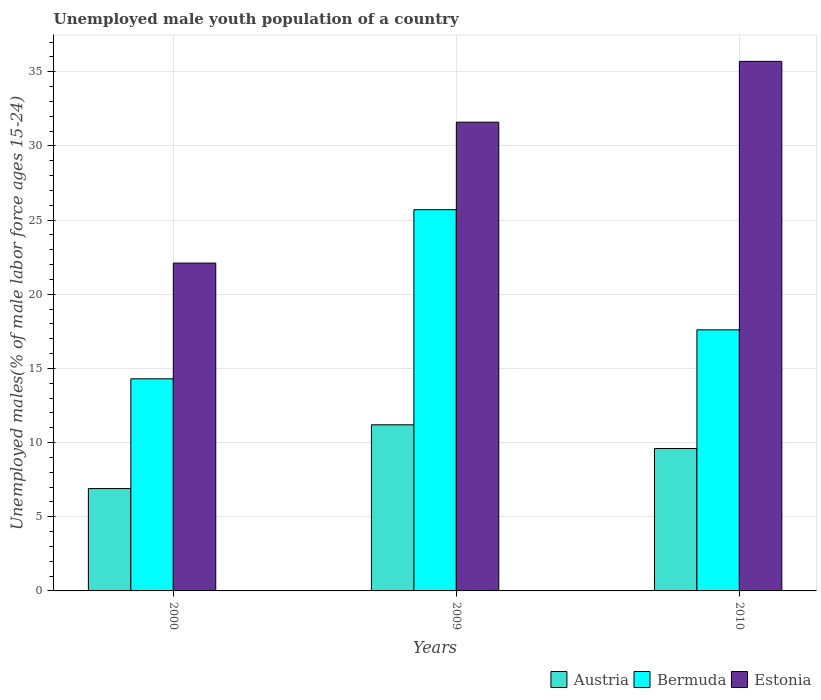Are the number of bars on each tick of the X-axis equal?
Your response must be concise. Yes. How many bars are there on the 3rd tick from the left?
Your answer should be very brief. 3. How many bars are there on the 2nd tick from the right?
Your answer should be very brief. 3. What is the percentage of unemployed male youth population in Estonia in 2000?
Ensure brevity in your answer.  22.1. Across all years, what is the maximum percentage of unemployed male youth population in Bermuda?
Provide a succinct answer. 25.7. Across all years, what is the minimum percentage of unemployed male youth population in Estonia?
Offer a very short reply. 22.1. In which year was the percentage of unemployed male youth population in Estonia minimum?
Provide a short and direct response. 2000. What is the total percentage of unemployed male youth population in Bermuda in the graph?
Ensure brevity in your answer.  57.6. What is the difference between the percentage of unemployed male youth population in Bermuda in 2000 and that in 2010?
Offer a very short reply. -3.3. What is the difference between the percentage of unemployed male youth population in Bermuda in 2000 and the percentage of unemployed male youth population in Austria in 2010?
Give a very brief answer. 4.7. What is the average percentage of unemployed male youth population in Austria per year?
Provide a succinct answer. 9.23. In the year 2010, what is the difference between the percentage of unemployed male youth population in Austria and percentage of unemployed male youth population in Estonia?
Your answer should be very brief. -26.1. In how many years, is the percentage of unemployed male youth population in Austria greater than 35 %?
Make the answer very short. 0. What is the ratio of the percentage of unemployed male youth population in Bermuda in 2000 to that in 2009?
Provide a short and direct response. 0.56. Is the percentage of unemployed male youth population in Bermuda in 2009 less than that in 2010?
Make the answer very short. No. What is the difference between the highest and the second highest percentage of unemployed male youth population in Estonia?
Provide a short and direct response. 4.1. What is the difference between the highest and the lowest percentage of unemployed male youth population in Austria?
Your answer should be very brief. 4.3. Is the sum of the percentage of unemployed male youth population in Austria in 2009 and 2010 greater than the maximum percentage of unemployed male youth population in Estonia across all years?
Your response must be concise. No. Are all the bars in the graph horizontal?
Offer a very short reply. No. How many legend labels are there?
Your answer should be compact. 3. How are the legend labels stacked?
Offer a terse response. Horizontal. What is the title of the graph?
Offer a very short reply. Unemployed male youth population of a country. Does "Singapore" appear as one of the legend labels in the graph?
Make the answer very short. No. What is the label or title of the X-axis?
Provide a short and direct response. Years. What is the label or title of the Y-axis?
Your answer should be very brief. Unemployed males(% of male labor force ages 15-24). What is the Unemployed males(% of male labor force ages 15-24) in Austria in 2000?
Your answer should be very brief. 6.9. What is the Unemployed males(% of male labor force ages 15-24) of Bermuda in 2000?
Your response must be concise. 14.3. What is the Unemployed males(% of male labor force ages 15-24) in Estonia in 2000?
Your answer should be very brief. 22.1. What is the Unemployed males(% of male labor force ages 15-24) in Austria in 2009?
Provide a succinct answer. 11.2. What is the Unemployed males(% of male labor force ages 15-24) of Bermuda in 2009?
Give a very brief answer. 25.7. What is the Unemployed males(% of male labor force ages 15-24) of Estonia in 2009?
Provide a short and direct response. 31.6. What is the Unemployed males(% of male labor force ages 15-24) of Austria in 2010?
Your answer should be very brief. 9.6. What is the Unemployed males(% of male labor force ages 15-24) of Bermuda in 2010?
Make the answer very short. 17.6. What is the Unemployed males(% of male labor force ages 15-24) of Estonia in 2010?
Give a very brief answer. 35.7. Across all years, what is the maximum Unemployed males(% of male labor force ages 15-24) in Austria?
Make the answer very short. 11.2. Across all years, what is the maximum Unemployed males(% of male labor force ages 15-24) of Bermuda?
Give a very brief answer. 25.7. Across all years, what is the maximum Unemployed males(% of male labor force ages 15-24) of Estonia?
Your answer should be compact. 35.7. Across all years, what is the minimum Unemployed males(% of male labor force ages 15-24) in Austria?
Ensure brevity in your answer.  6.9. Across all years, what is the minimum Unemployed males(% of male labor force ages 15-24) of Bermuda?
Offer a very short reply. 14.3. Across all years, what is the minimum Unemployed males(% of male labor force ages 15-24) of Estonia?
Provide a short and direct response. 22.1. What is the total Unemployed males(% of male labor force ages 15-24) in Austria in the graph?
Provide a short and direct response. 27.7. What is the total Unemployed males(% of male labor force ages 15-24) in Bermuda in the graph?
Offer a very short reply. 57.6. What is the total Unemployed males(% of male labor force ages 15-24) of Estonia in the graph?
Your answer should be very brief. 89.4. What is the difference between the Unemployed males(% of male labor force ages 15-24) of Austria in 2000 and that in 2009?
Give a very brief answer. -4.3. What is the difference between the Unemployed males(% of male labor force ages 15-24) in Bermuda in 2000 and that in 2009?
Offer a terse response. -11.4. What is the difference between the Unemployed males(% of male labor force ages 15-24) of Estonia in 2000 and that in 2010?
Provide a succinct answer. -13.6. What is the difference between the Unemployed males(% of male labor force ages 15-24) in Austria in 2009 and that in 2010?
Provide a succinct answer. 1.6. What is the difference between the Unemployed males(% of male labor force ages 15-24) in Bermuda in 2009 and that in 2010?
Your answer should be very brief. 8.1. What is the difference between the Unemployed males(% of male labor force ages 15-24) in Estonia in 2009 and that in 2010?
Ensure brevity in your answer.  -4.1. What is the difference between the Unemployed males(% of male labor force ages 15-24) in Austria in 2000 and the Unemployed males(% of male labor force ages 15-24) in Bermuda in 2009?
Provide a succinct answer. -18.8. What is the difference between the Unemployed males(% of male labor force ages 15-24) of Austria in 2000 and the Unemployed males(% of male labor force ages 15-24) of Estonia in 2009?
Your response must be concise. -24.7. What is the difference between the Unemployed males(% of male labor force ages 15-24) in Bermuda in 2000 and the Unemployed males(% of male labor force ages 15-24) in Estonia in 2009?
Offer a terse response. -17.3. What is the difference between the Unemployed males(% of male labor force ages 15-24) of Austria in 2000 and the Unemployed males(% of male labor force ages 15-24) of Bermuda in 2010?
Provide a short and direct response. -10.7. What is the difference between the Unemployed males(% of male labor force ages 15-24) of Austria in 2000 and the Unemployed males(% of male labor force ages 15-24) of Estonia in 2010?
Offer a very short reply. -28.8. What is the difference between the Unemployed males(% of male labor force ages 15-24) in Bermuda in 2000 and the Unemployed males(% of male labor force ages 15-24) in Estonia in 2010?
Your answer should be compact. -21.4. What is the difference between the Unemployed males(% of male labor force ages 15-24) in Austria in 2009 and the Unemployed males(% of male labor force ages 15-24) in Bermuda in 2010?
Your answer should be compact. -6.4. What is the difference between the Unemployed males(% of male labor force ages 15-24) of Austria in 2009 and the Unemployed males(% of male labor force ages 15-24) of Estonia in 2010?
Ensure brevity in your answer.  -24.5. What is the average Unemployed males(% of male labor force ages 15-24) in Austria per year?
Your response must be concise. 9.23. What is the average Unemployed males(% of male labor force ages 15-24) in Estonia per year?
Provide a succinct answer. 29.8. In the year 2000, what is the difference between the Unemployed males(% of male labor force ages 15-24) in Austria and Unemployed males(% of male labor force ages 15-24) in Estonia?
Keep it short and to the point. -15.2. In the year 2009, what is the difference between the Unemployed males(% of male labor force ages 15-24) of Austria and Unemployed males(% of male labor force ages 15-24) of Bermuda?
Your answer should be compact. -14.5. In the year 2009, what is the difference between the Unemployed males(% of male labor force ages 15-24) in Austria and Unemployed males(% of male labor force ages 15-24) in Estonia?
Offer a terse response. -20.4. In the year 2010, what is the difference between the Unemployed males(% of male labor force ages 15-24) of Austria and Unemployed males(% of male labor force ages 15-24) of Estonia?
Your answer should be very brief. -26.1. In the year 2010, what is the difference between the Unemployed males(% of male labor force ages 15-24) in Bermuda and Unemployed males(% of male labor force ages 15-24) in Estonia?
Make the answer very short. -18.1. What is the ratio of the Unemployed males(% of male labor force ages 15-24) in Austria in 2000 to that in 2009?
Ensure brevity in your answer.  0.62. What is the ratio of the Unemployed males(% of male labor force ages 15-24) of Bermuda in 2000 to that in 2009?
Ensure brevity in your answer.  0.56. What is the ratio of the Unemployed males(% of male labor force ages 15-24) in Estonia in 2000 to that in 2009?
Ensure brevity in your answer.  0.7. What is the ratio of the Unemployed males(% of male labor force ages 15-24) of Austria in 2000 to that in 2010?
Offer a very short reply. 0.72. What is the ratio of the Unemployed males(% of male labor force ages 15-24) in Bermuda in 2000 to that in 2010?
Keep it short and to the point. 0.81. What is the ratio of the Unemployed males(% of male labor force ages 15-24) in Estonia in 2000 to that in 2010?
Give a very brief answer. 0.62. What is the ratio of the Unemployed males(% of male labor force ages 15-24) of Austria in 2009 to that in 2010?
Your answer should be compact. 1.17. What is the ratio of the Unemployed males(% of male labor force ages 15-24) of Bermuda in 2009 to that in 2010?
Provide a succinct answer. 1.46. What is the ratio of the Unemployed males(% of male labor force ages 15-24) of Estonia in 2009 to that in 2010?
Ensure brevity in your answer.  0.89. What is the difference between the highest and the second highest Unemployed males(% of male labor force ages 15-24) in Austria?
Offer a very short reply. 1.6. What is the difference between the highest and the second highest Unemployed males(% of male labor force ages 15-24) in Bermuda?
Offer a very short reply. 8.1. What is the difference between the highest and the second highest Unemployed males(% of male labor force ages 15-24) in Estonia?
Your answer should be compact. 4.1. What is the difference between the highest and the lowest Unemployed males(% of male labor force ages 15-24) in Austria?
Your answer should be very brief. 4.3. What is the difference between the highest and the lowest Unemployed males(% of male labor force ages 15-24) of Bermuda?
Make the answer very short. 11.4. 